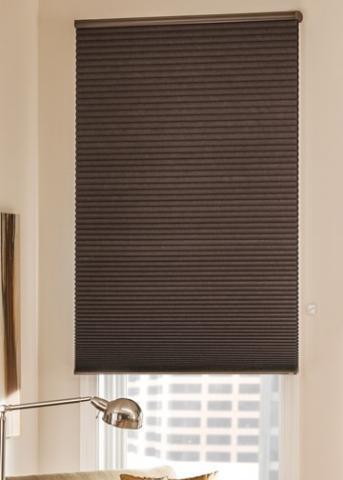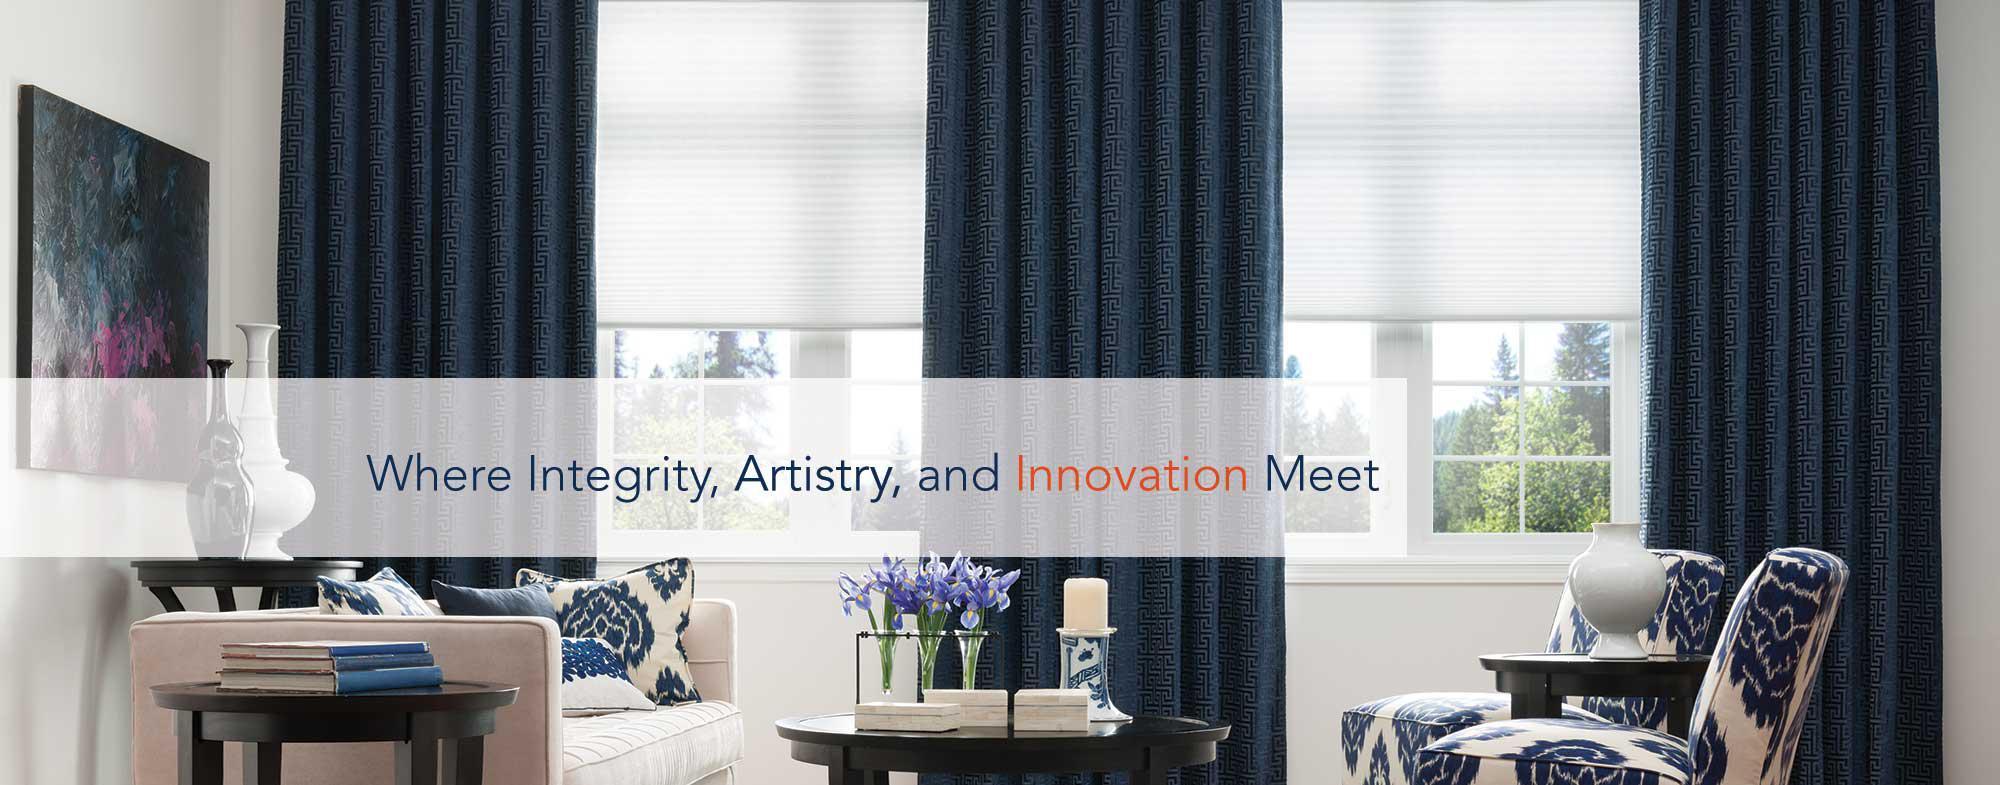The first image is the image on the left, the second image is the image on the right. For the images shown, is this caption "The left and right image contains the a total of four window." true? Answer yes or no. No. 